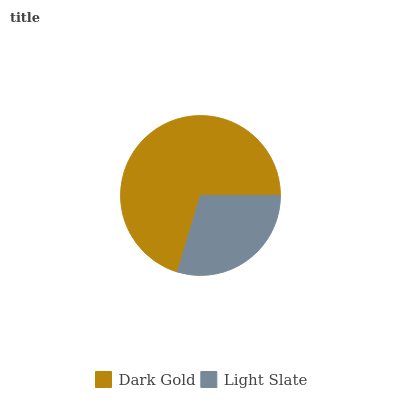Is Light Slate the minimum?
Answer yes or no. Yes. Is Dark Gold the maximum?
Answer yes or no. Yes. Is Light Slate the maximum?
Answer yes or no. No. Is Dark Gold greater than Light Slate?
Answer yes or no. Yes. Is Light Slate less than Dark Gold?
Answer yes or no. Yes. Is Light Slate greater than Dark Gold?
Answer yes or no. No. Is Dark Gold less than Light Slate?
Answer yes or no. No. Is Dark Gold the high median?
Answer yes or no. Yes. Is Light Slate the low median?
Answer yes or no. Yes. Is Light Slate the high median?
Answer yes or no. No. Is Dark Gold the low median?
Answer yes or no. No. 